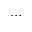Convert formula to latex. <formula><loc_0><loc_0><loc_500><loc_500>\dots</formula> 